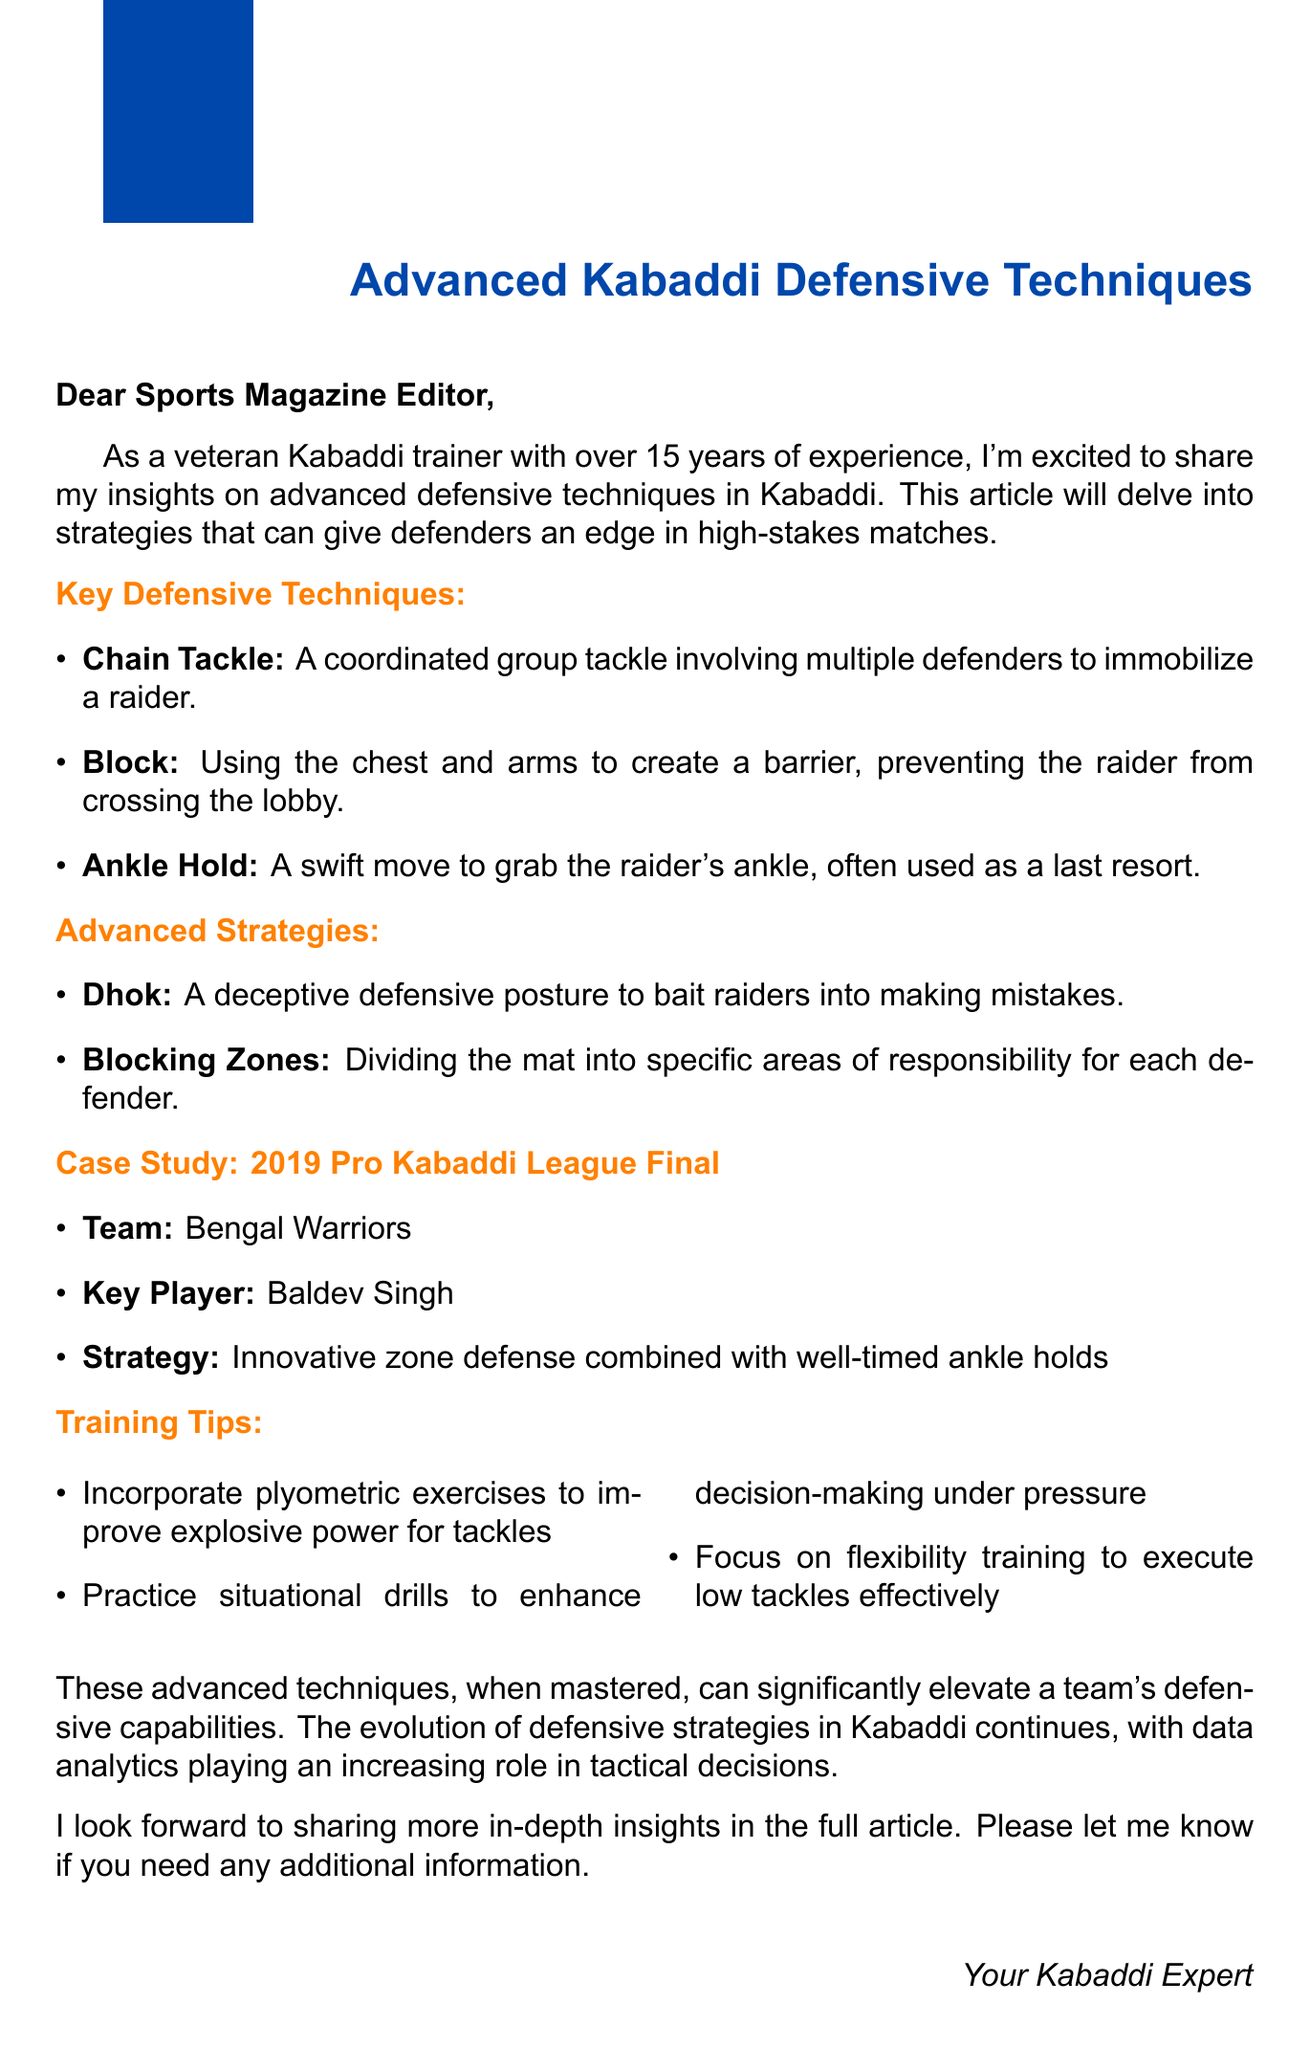What is the main topic of the article? The article focuses on advanced defensive techniques in Kabaddi.
Answer: advanced defensive techniques in Kabaddi Who is the key player mentioned in the case study? The case study mentions Baldev Singh as the key player.
Answer: Baldev Singh What technique involves multiple defenders? The technique that involves multiple defenders is called a Chain Tackle.
Answer: Chain Tackle What is one of the advanced strategies mentioned? One of the advanced strategies mentioned is Dhok.
Answer: Dhok What year was the case study event held? The case study event, the Pro Kabaddi League Final, was held in 2019.
Answer: 2019 What type of exercises are recommended for improving tackle power? The document recommends incorporating plyometric exercises for improving tackle power.
Answer: plyometric exercises What does the conclusion highlight about defensive techniques? The conclusion highlights that mastering these techniques can elevate a team's defensive capabilities.
Answer: elevate a team's defensive capabilities What role is increasingly influencing tactical decisions in Kabaddi? Data analytics is playing an increasing role in tactical decisions.
Answer: Data analytics 